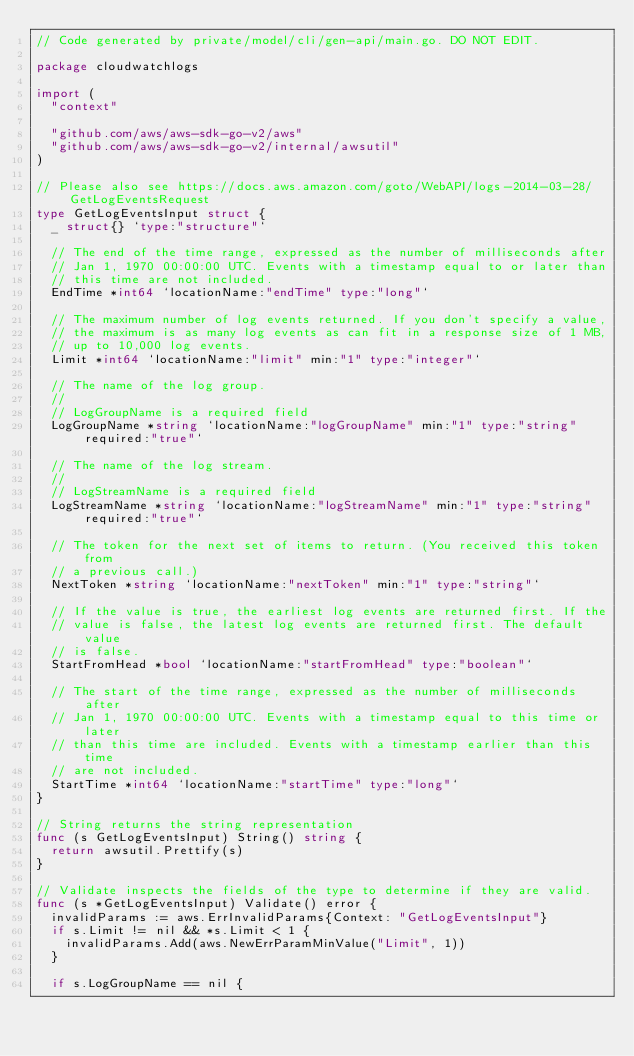<code> <loc_0><loc_0><loc_500><loc_500><_Go_>// Code generated by private/model/cli/gen-api/main.go. DO NOT EDIT.

package cloudwatchlogs

import (
	"context"

	"github.com/aws/aws-sdk-go-v2/aws"
	"github.com/aws/aws-sdk-go-v2/internal/awsutil"
)

// Please also see https://docs.aws.amazon.com/goto/WebAPI/logs-2014-03-28/GetLogEventsRequest
type GetLogEventsInput struct {
	_ struct{} `type:"structure"`

	// The end of the time range, expressed as the number of milliseconds after
	// Jan 1, 1970 00:00:00 UTC. Events with a timestamp equal to or later than
	// this time are not included.
	EndTime *int64 `locationName:"endTime" type:"long"`

	// The maximum number of log events returned. If you don't specify a value,
	// the maximum is as many log events as can fit in a response size of 1 MB,
	// up to 10,000 log events.
	Limit *int64 `locationName:"limit" min:"1" type:"integer"`

	// The name of the log group.
	//
	// LogGroupName is a required field
	LogGroupName *string `locationName:"logGroupName" min:"1" type:"string" required:"true"`

	// The name of the log stream.
	//
	// LogStreamName is a required field
	LogStreamName *string `locationName:"logStreamName" min:"1" type:"string" required:"true"`

	// The token for the next set of items to return. (You received this token from
	// a previous call.)
	NextToken *string `locationName:"nextToken" min:"1" type:"string"`

	// If the value is true, the earliest log events are returned first. If the
	// value is false, the latest log events are returned first. The default value
	// is false.
	StartFromHead *bool `locationName:"startFromHead" type:"boolean"`

	// The start of the time range, expressed as the number of milliseconds after
	// Jan 1, 1970 00:00:00 UTC. Events with a timestamp equal to this time or later
	// than this time are included. Events with a timestamp earlier than this time
	// are not included.
	StartTime *int64 `locationName:"startTime" type:"long"`
}

// String returns the string representation
func (s GetLogEventsInput) String() string {
	return awsutil.Prettify(s)
}

// Validate inspects the fields of the type to determine if they are valid.
func (s *GetLogEventsInput) Validate() error {
	invalidParams := aws.ErrInvalidParams{Context: "GetLogEventsInput"}
	if s.Limit != nil && *s.Limit < 1 {
		invalidParams.Add(aws.NewErrParamMinValue("Limit", 1))
	}

	if s.LogGroupName == nil {</code> 